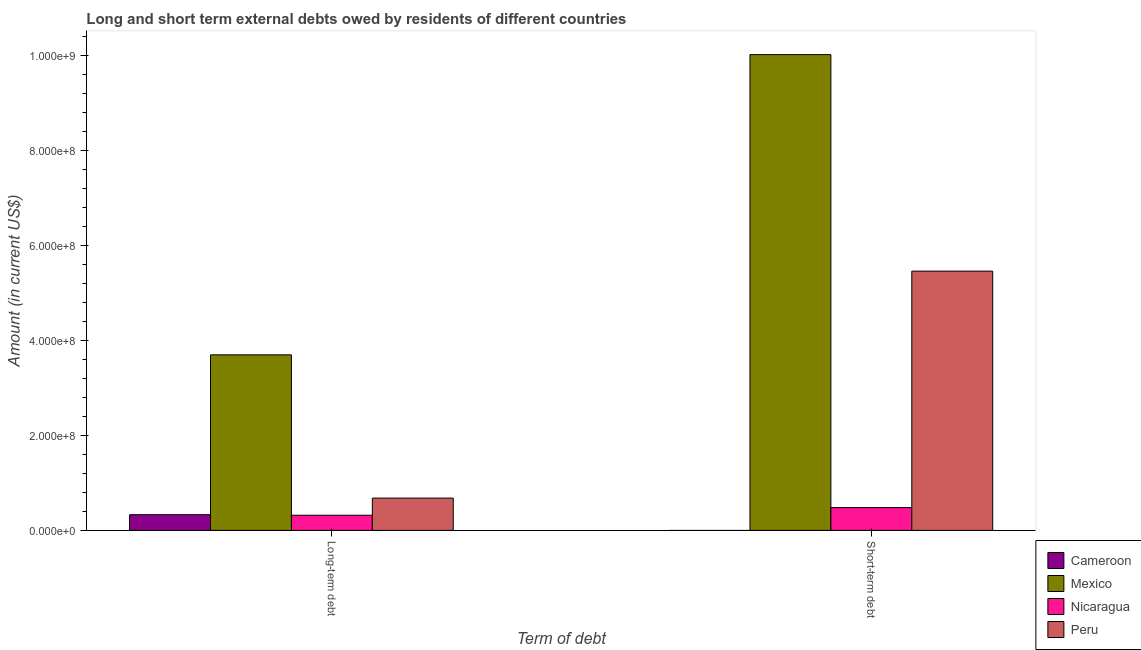How many different coloured bars are there?
Your answer should be very brief. 4. How many groups of bars are there?
Give a very brief answer. 2. Are the number of bars per tick equal to the number of legend labels?
Provide a short and direct response. No. Are the number of bars on each tick of the X-axis equal?
Offer a very short reply. No. How many bars are there on the 2nd tick from the left?
Offer a terse response. 3. How many bars are there on the 1st tick from the right?
Your response must be concise. 3. What is the label of the 2nd group of bars from the left?
Your answer should be very brief. Short-term debt. What is the short-term debts owed by residents in Nicaragua?
Provide a short and direct response. 4.80e+07. Across all countries, what is the maximum short-term debts owed by residents?
Offer a very short reply. 1.00e+09. In which country was the short-term debts owed by residents maximum?
Keep it short and to the point. Mexico. What is the total short-term debts owed by residents in the graph?
Offer a very short reply. 1.60e+09. What is the difference between the long-term debts owed by residents in Mexico and that in Nicaragua?
Your response must be concise. 3.38e+08. What is the difference between the long-term debts owed by residents in Mexico and the short-term debts owed by residents in Nicaragua?
Give a very brief answer. 3.22e+08. What is the average long-term debts owed by residents per country?
Ensure brevity in your answer.  1.26e+08. What is the difference between the long-term debts owed by residents and short-term debts owed by residents in Nicaragua?
Make the answer very short. -1.61e+07. In how many countries, is the long-term debts owed by residents greater than 360000000 US$?
Your answer should be compact. 1. What is the ratio of the long-term debts owed by residents in Nicaragua to that in Cameroon?
Keep it short and to the point. 0.97. In how many countries, is the short-term debts owed by residents greater than the average short-term debts owed by residents taken over all countries?
Make the answer very short. 2. How many bars are there?
Offer a very short reply. 7. What is the difference between two consecutive major ticks on the Y-axis?
Keep it short and to the point. 2.00e+08. Does the graph contain any zero values?
Ensure brevity in your answer.  Yes. Does the graph contain grids?
Keep it short and to the point. No. Where does the legend appear in the graph?
Your response must be concise. Bottom right. How are the legend labels stacked?
Ensure brevity in your answer.  Vertical. What is the title of the graph?
Offer a terse response. Long and short term external debts owed by residents of different countries. Does "Indonesia" appear as one of the legend labels in the graph?
Provide a succinct answer. No. What is the label or title of the X-axis?
Keep it short and to the point. Term of debt. What is the Amount (in current US$) of Cameroon in Long-term debt?
Provide a succinct answer. 3.30e+07. What is the Amount (in current US$) in Mexico in Long-term debt?
Offer a terse response. 3.70e+08. What is the Amount (in current US$) in Nicaragua in Long-term debt?
Ensure brevity in your answer.  3.19e+07. What is the Amount (in current US$) of Peru in Long-term debt?
Provide a succinct answer. 6.80e+07. What is the Amount (in current US$) in Mexico in Short-term debt?
Provide a short and direct response. 1.00e+09. What is the Amount (in current US$) of Nicaragua in Short-term debt?
Provide a succinct answer. 4.80e+07. What is the Amount (in current US$) of Peru in Short-term debt?
Your response must be concise. 5.46e+08. Across all Term of debt, what is the maximum Amount (in current US$) of Cameroon?
Your response must be concise. 3.30e+07. Across all Term of debt, what is the maximum Amount (in current US$) in Mexico?
Ensure brevity in your answer.  1.00e+09. Across all Term of debt, what is the maximum Amount (in current US$) of Nicaragua?
Provide a short and direct response. 4.80e+07. Across all Term of debt, what is the maximum Amount (in current US$) in Peru?
Offer a very short reply. 5.46e+08. Across all Term of debt, what is the minimum Amount (in current US$) in Mexico?
Your response must be concise. 3.70e+08. Across all Term of debt, what is the minimum Amount (in current US$) in Nicaragua?
Provide a succinct answer. 3.19e+07. Across all Term of debt, what is the minimum Amount (in current US$) in Peru?
Ensure brevity in your answer.  6.80e+07. What is the total Amount (in current US$) in Cameroon in the graph?
Keep it short and to the point. 3.30e+07. What is the total Amount (in current US$) in Mexico in the graph?
Offer a terse response. 1.37e+09. What is the total Amount (in current US$) in Nicaragua in the graph?
Offer a very short reply. 7.99e+07. What is the total Amount (in current US$) of Peru in the graph?
Provide a short and direct response. 6.14e+08. What is the difference between the Amount (in current US$) in Mexico in Long-term debt and that in Short-term debt?
Your answer should be very brief. -6.32e+08. What is the difference between the Amount (in current US$) of Nicaragua in Long-term debt and that in Short-term debt?
Offer a terse response. -1.61e+07. What is the difference between the Amount (in current US$) of Peru in Long-term debt and that in Short-term debt?
Offer a terse response. -4.78e+08. What is the difference between the Amount (in current US$) of Cameroon in Long-term debt and the Amount (in current US$) of Mexico in Short-term debt?
Offer a very short reply. -9.69e+08. What is the difference between the Amount (in current US$) in Cameroon in Long-term debt and the Amount (in current US$) in Nicaragua in Short-term debt?
Your answer should be compact. -1.50e+07. What is the difference between the Amount (in current US$) in Cameroon in Long-term debt and the Amount (in current US$) in Peru in Short-term debt?
Ensure brevity in your answer.  -5.13e+08. What is the difference between the Amount (in current US$) of Mexico in Long-term debt and the Amount (in current US$) of Nicaragua in Short-term debt?
Ensure brevity in your answer.  3.22e+08. What is the difference between the Amount (in current US$) in Mexico in Long-term debt and the Amount (in current US$) in Peru in Short-term debt?
Ensure brevity in your answer.  -1.76e+08. What is the difference between the Amount (in current US$) of Nicaragua in Long-term debt and the Amount (in current US$) of Peru in Short-term debt?
Your response must be concise. -5.14e+08. What is the average Amount (in current US$) of Cameroon per Term of debt?
Provide a short and direct response. 1.65e+07. What is the average Amount (in current US$) of Mexico per Term of debt?
Make the answer very short. 6.86e+08. What is the average Amount (in current US$) in Nicaragua per Term of debt?
Your answer should be compact. 4.00e+07. What is the average Amount (in current US$) in Peru per Term of debt?
Offer a terse response. 3.07e+08. What is the difference between the Amount (in current US$) of Cameroon and Amount (in current US$) of Mexico in Long-term debt?
Ensure brevity in your answer.  -3.37e+08. What is the difference between the Amount (in current US$) in Cameroon and Amount (in current US$) in Nicaragua in Long-term debt?
Offer a terse response. 1.13e+06. What is the difference between the Amount (in current US$) in Cameroon and Amount (in current US$) in Peru in Long-term debt?
Your answer should be compact. -3.49e+07. What is the difference between the Amount (in current US$) of Mexico and Amount (in current US$) of Nicaragua in Long-term debt?
Provide a succinct answer. 3.38e+08. What is the difference between the Amount (in current US$) of Mexico and Amount (in current US$) of Peru in Long-term debt?
Ensure brevity in your answer.  3.02e+08. What is the difference between the Amount (in current US$) of Nicaragua and Amount (in current US$) of Peru in Long-term debt?
Offer a terse response. -3.61e+07. What is the difference between the Amount (in current US$) of Mexico and Amount (in current US$) of Nicaragua in Short-term debt?
Keep it short and to the point. 9.54e+08. What is the difference between the Amount (in current US$) of Mexico and Amount (in current US$) of Peru in Short-term debt?
Provide a succinct answer. 4.56e+08. What is the difference between the Amount (in current US$) in Nicaragua and Amount (in current US$) in Peru in Short-term debt?
Offer a very short reply. -4.98e+08. What is the ratio of the Amount (in current US$) of Mexico in Long-term debt to that in Short-term debt?
Ensure brevity in your answer.  0.37. What is the ratio of the Amount (in current US$) of Nicaragua in Long-term debt to that in Short-term debt?
Give a very brief answer. 0.66. What is the ratio of the Amount (in current US$) of Peru in Long-term debt to that in Short-term debt?
Make the answer very short. 0.12. What is the difference between the highest and the second highest Amount (in current US$) of Mexico?
Ensure brevity in your answer.  6.32e+08. What is the difference between the highest and the second highest Amount (in current US$) in Nicaragua?
Your answer should be compact. 1.61e+07. What is the difference between the highest and the second highest Amount (in current US$) in Peru?
Give a very brief answer. 4.78e+08. What is the difference between the highest and the lowest Amount (in current US$) in Cameroon?
Keep it short and to the point. 3.30e+07. What is the difference between the highest and the lowest Amount (in current US$) in Mexico?
Provide a succinct answer. 6.32e+08. What is the difference between the highest and the lowest Amount (in current US$) in Nicaragua?
Your response must be concise. 1.61e+07. What is the difference between the highest and the lowest Amount (in current US$) of Peru?
Provide a succinct answer. 4.78e+08. 